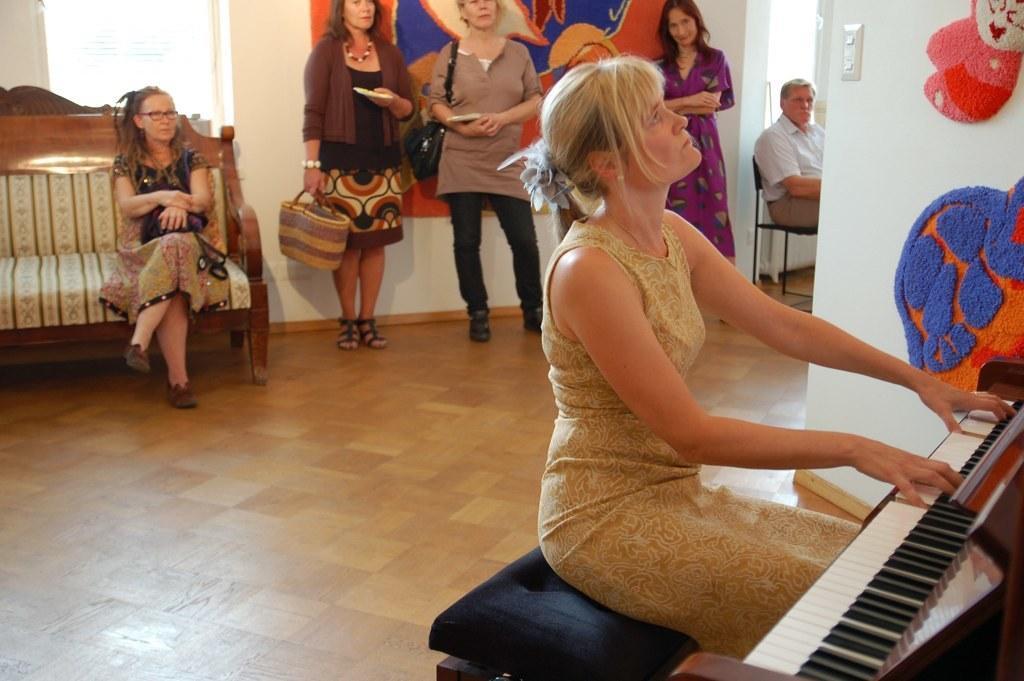Please provide a concise description of this image. On the background we can see window and three women standing near to the wall. Here we can see a man sitting on a chair. We can see a woman , wearing spectacles sitting on sofa. This is a floor. Here we can see a women sitting on stool and playing a piano , a musical instrument. We can see woolen handmade, handicrafts on a wall. 